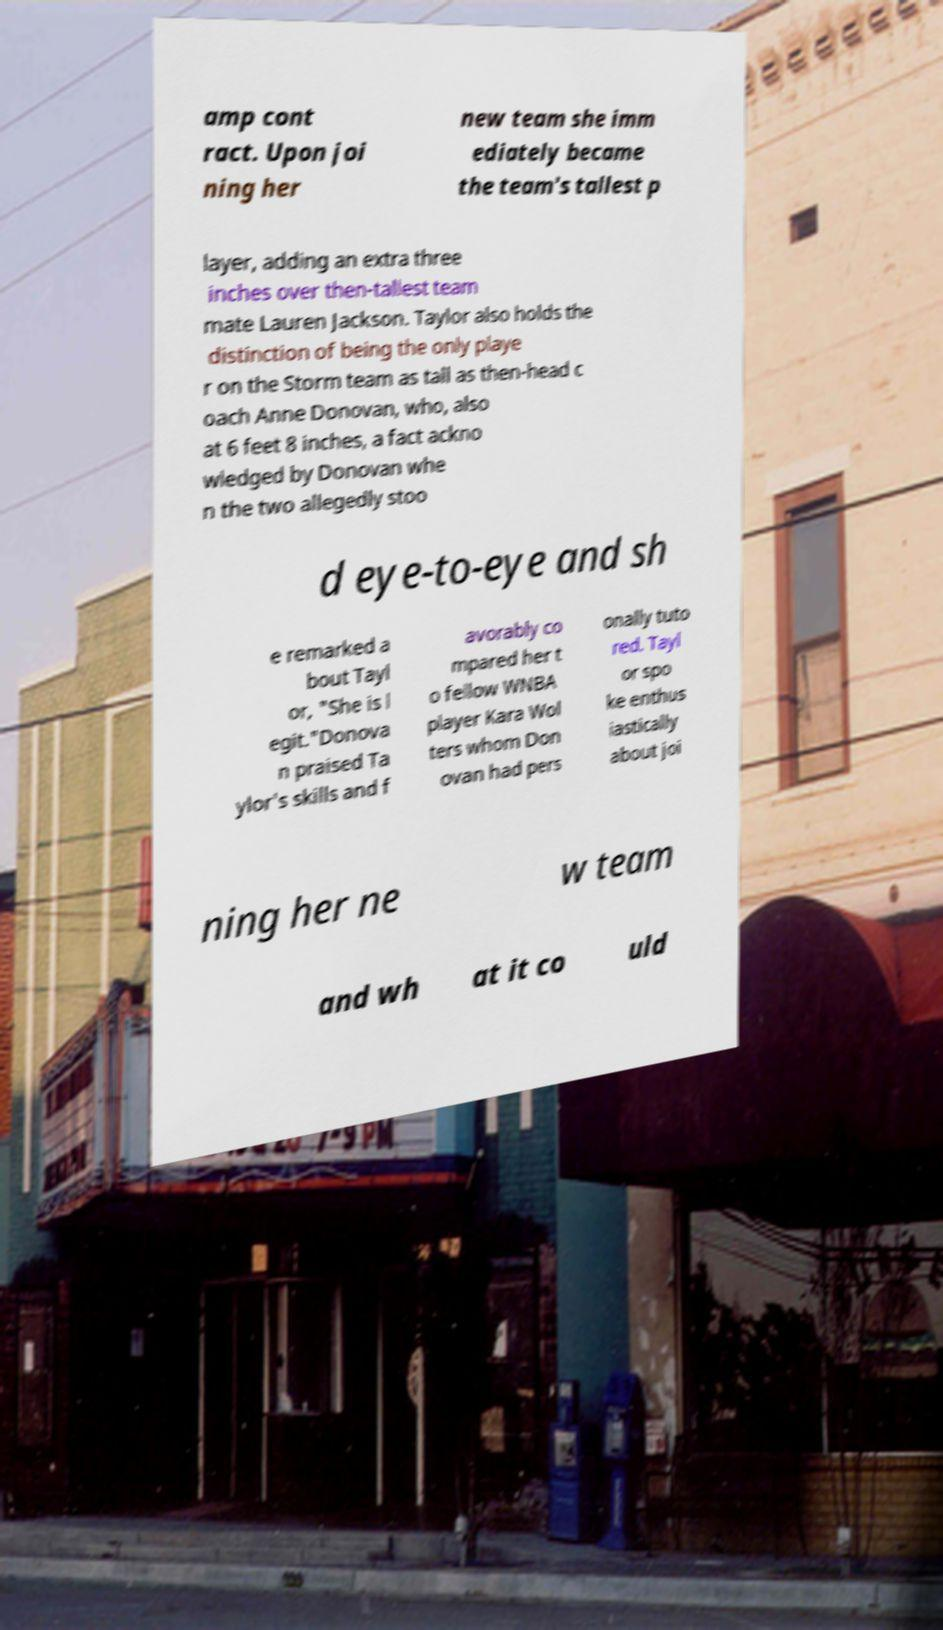Could you assist in decoding the text presented in this image and type it out clearly? amp cont ract. Upon joi ning her new team she imm ediately became the team's tallest p layer, adding an extra three inches over then-tallest team mate Lauren Jackson. Taylor also holds the distinction of being the only playe r on the Storm team as tall as then-head c oach Anne Donovan, who, also at 6 feet 8 inches, a fact ackno wledged by Donovan whe n the two allegedly stoo d eye-to-eye and sh e remarked a bout Tayl or, "She is l egit."Donova n praised Ta ylor's skills and f avorably co mpared her t o fellow WNBA player Kara Wol ters whom Don ovan had pers onally tuto red. Tayl or spo ke enthus iastically about joi ning her ne w team and wh at it co uld 